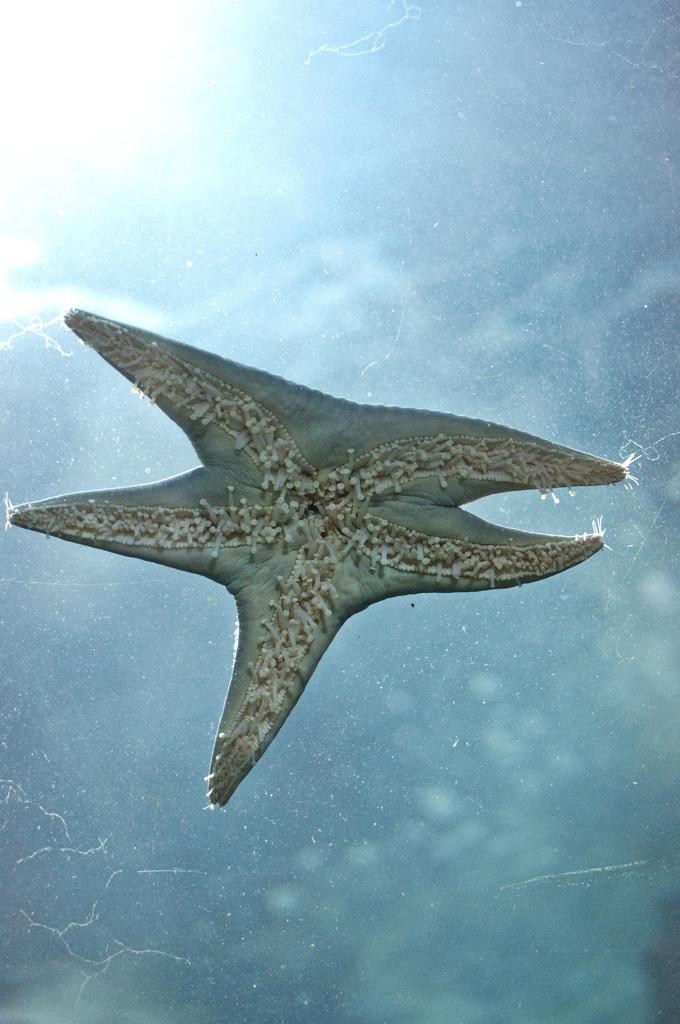Please provide a concise description of this image. In the center of the picture we can see a starfish, around the starfish it is light blue in color. 